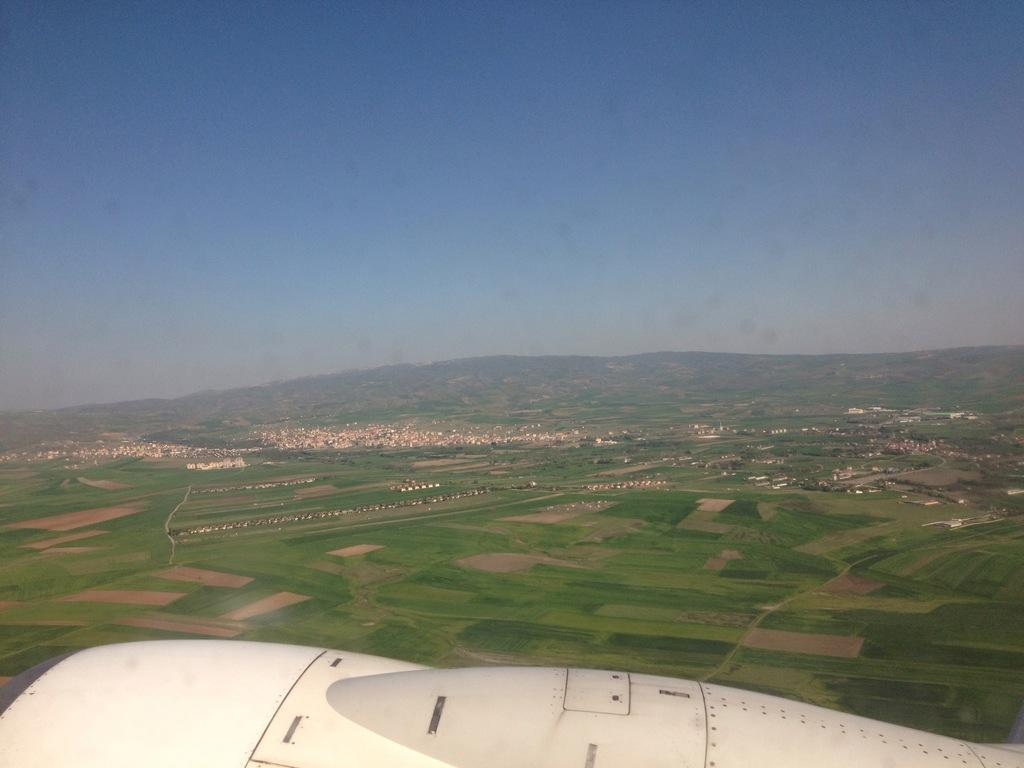What is the main subject of the image? There is a flying jet in the image. Where is the jet located? The jet is in the sky. What color is the sky in the image? The sky is pale blue. What type of ground surface can be seen in the image? There is grass visible in the image. What type of prose can be heard coming from the jet in the image? There is no indication in the image that the jet is producing any prose, as jets do not have the ability to produce or convey written or spoken language. 